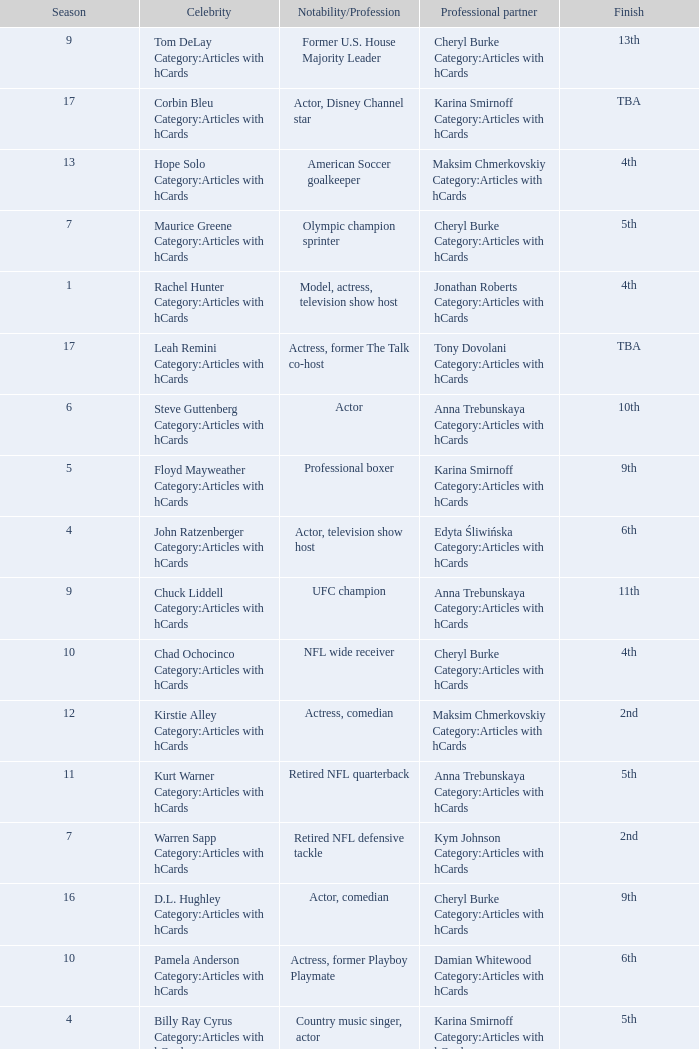What was the profession of the celebrity who was featured on season 15 and finished 7th place? Actress, comedian. 